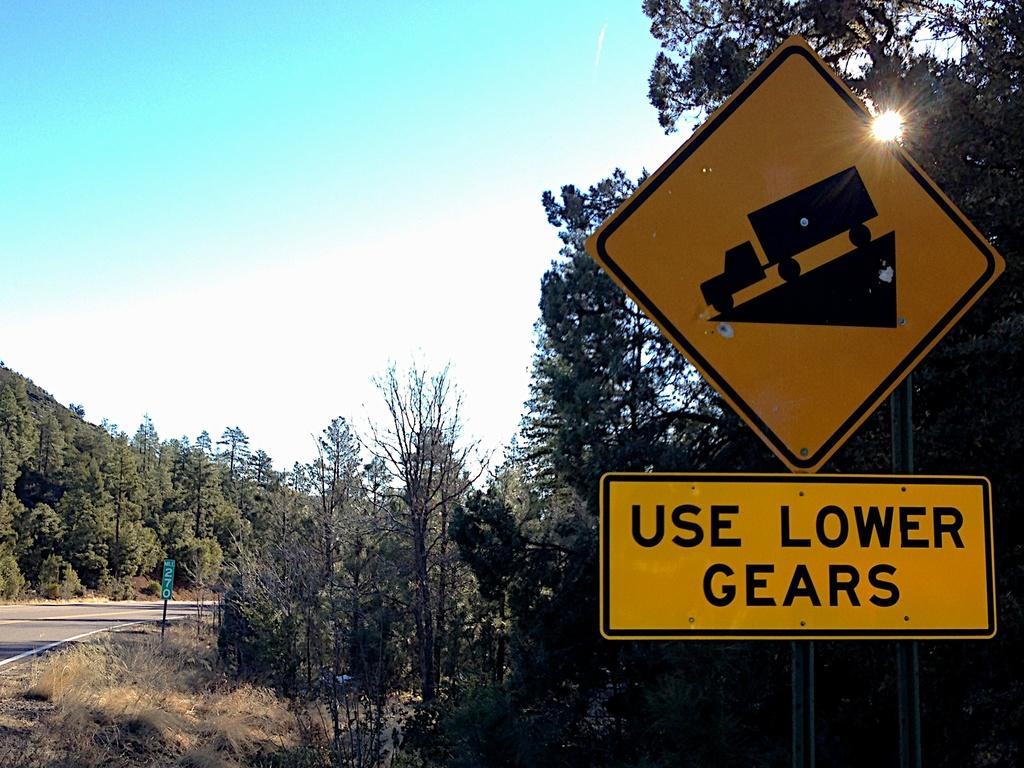<image>
Offer a succinct explanation of the picture presented. Photo of a downhill grade for a tractor trailers reading use lower gears. 